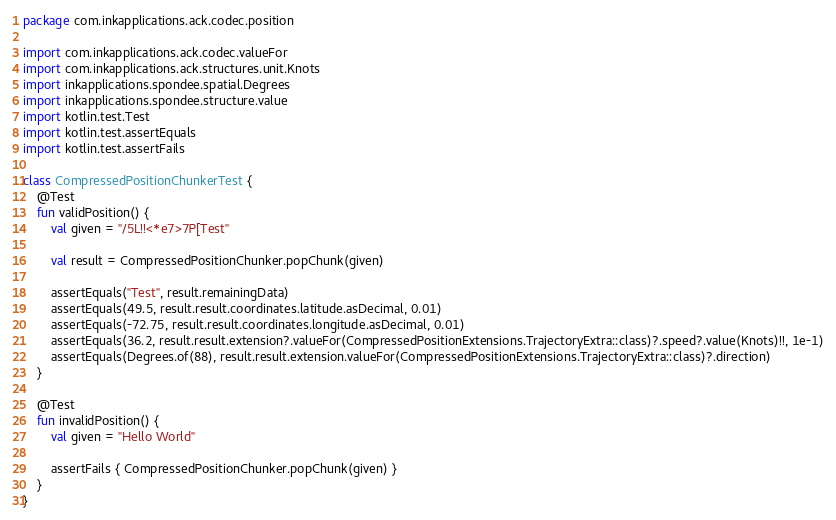<code> <loc_0><loc_0><loc_500><loc_500><_Kotlin_>package com.inkapplications.ack.codec.position

import com.inkapplications.ack.codec.valueFor
import com.inkapplications.ack.structures.unit.Knots
import inkapplications.spondee.spatial.Degrees
import inkapplications.spondee.structure.value
import kotlin.test.Test
import kotlin.test.assertEquals
import kotlin.test.assertFails

class CompressedPositionChunkerTest {
    @Test
    fun validPosition() {
        val given = "/5L!!<*e7>7P[Test"

        val result = CompressedPositionChunker.popChunk(given)

        assertEquals("Test", result.remainingData)
        assertEquals(49.5, result.result.coordinates.latitude.asDecimal, 0.01)
        assertEquals(-72.75, result.result.coordinates.longitude.asDecimal, 0.01)
        assertEquals(36.2, result.result.extension?.valueFor(CompressedPositionExtensions.TrajectoryExtra::class)?.speed?.value(Knots)!!, 1e-1)
        assertEquals(Degrees.of(88), result.result.extension.valueFor(CompressedPositionExtensions.TrajectoryExtra::class)?.direction)
    }

    @Test
    fun invalidPosition() {
        val given = "Hello World"

        assertFails { CompressedPositionChunker.popChunk(given) }
    }
}
</code> 